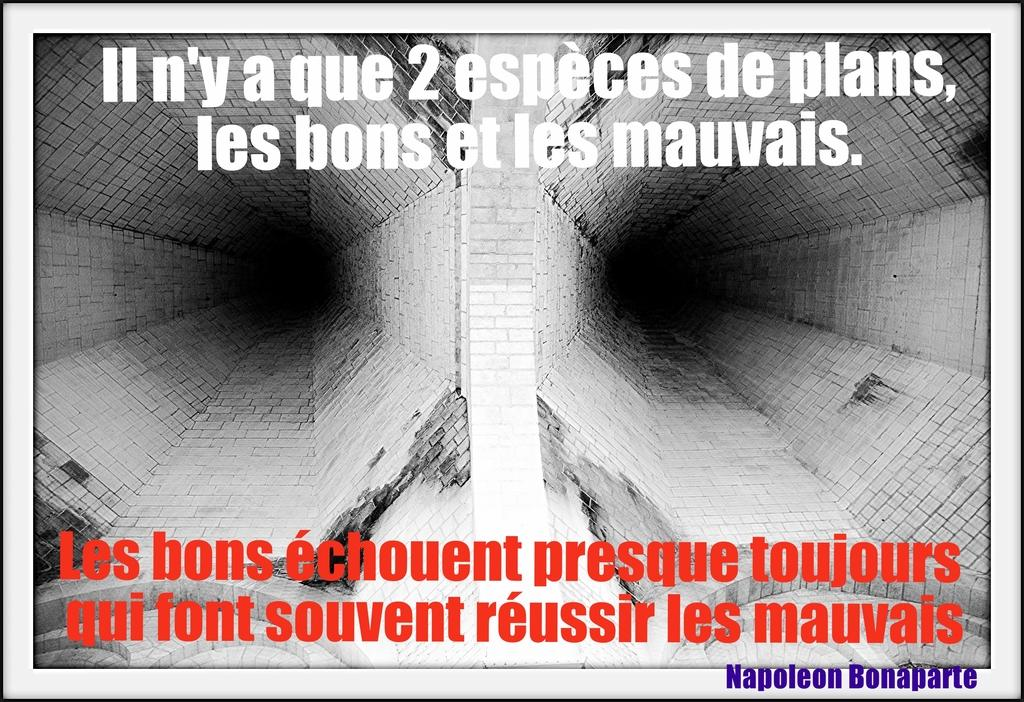<image>
Relay a brief, clear account of the picture shown. a spanish quote that is from Napoleon Bonaparte 